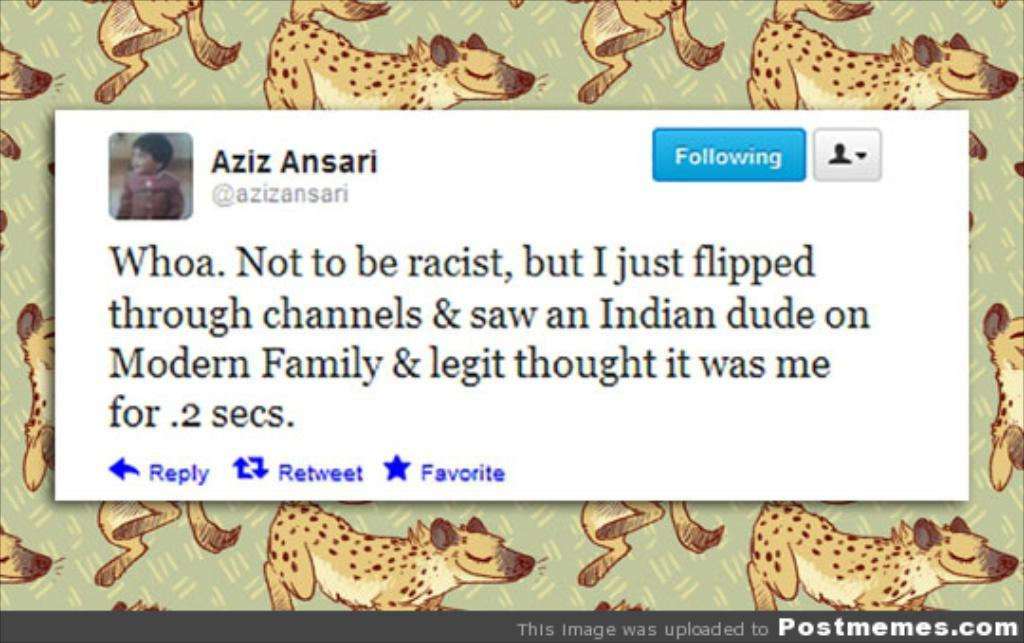What can be found in the image that contains text? There is writing in the image. What type of image is present in the image with text? There is a picture of a child in the image. What other images can be found in the image? There are animal pictures in the image. Is there any additional text in the image? Yes, there is more writing in the image. Can you see a knife being used by the child in the image? There is no knife present in the image, nor is a child using one. 